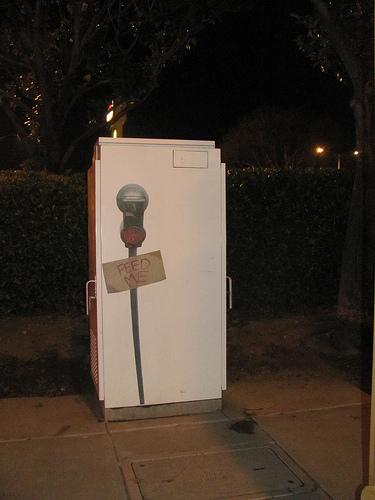Question: what time of day is it?
Choices:
A. Morning.
B. Noon.
C. Afternoon.
D. Night.
Answer with the letter. Answer: D Question: how many people are there?
Choices:
A. Two.
B. Three.
C. Zero.
D. Four.
Answer with the letter. Answer: C Question: what type of handles are on the door?
Choices:
A. Porcelain.
B. Wooden.
C. Metal.
D. Plastic.
Answer with the letter. Answer: C Question: where was this photo taken?
Choices:
A. Under a bridge.
B. Countryside.
C. Rooftop.
D. Streetside.
Answer with the letter. Answer: D Question: what does the sign say?
Choices:
A. Will work for food.
B. Feed me.
C. Broke and desperate.
D. California or bust.
Answer with the letter. Answer: B 